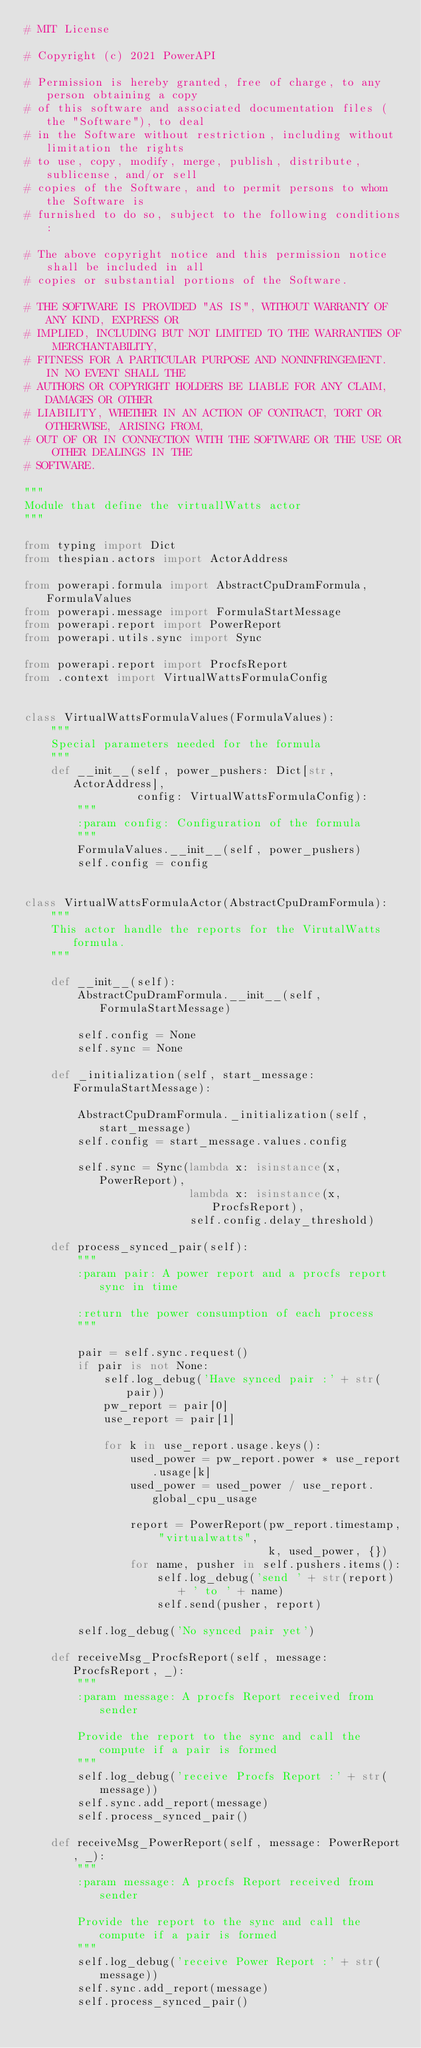<code> <loc_0><loc_0><loc_500><loc_500><_Python_># MIT License

# Copyright (c) 2021 PowerAPI

# Permission is hereby granted, free of charge, to any person obtaining a copy
# of this software and associated documentation files (the "Software"), to deal
# in the Software without restriction, including without limitation the rights
# to use, copy, modify, merge, publish, distribute, sublicense, and/or sell
# copies of the Software, and to permit persons to whom the Software is
# furnished to do so, subject to the following conditions:

# The above copyright notice and this permission notice shall be included in all
# copies or substantial portions of the Software.

# THE SOFTWARE IS PROVIDED "AS IS", WITHOUT WARRANTY OF ANY KIND, EXPRESS OR
# IMPLIED, INCLUDING BUT NOT LIMITED TO THE WARRANTIES OF MERCHANTABILITY,
# FITNESS FOR A PARTICULAR PURPOSE AND NONINFRINGEMENT. IN NO EVENT SHALL THE
# AUTHORS OR COPYRIGHT HOLDERS BE LIABLE FOR ANY CLAIM, DAMAGES OR OTHER
# LIABILITY, WHETHER IN AN ACTION OF CONTRACT, TORT OR OTHERWISE, ARISING FROM,
# OUT OF OR IN CONNECTION WITH THE SOFTWARE OR THE USE OR OTHER DEALINGS IN THE
# SOFTWARE.

"""
Module that define the virtuallWatts actor
"""

from typing import Dict
from thespian.actors import ActorAddress

from powerapi.formula import AbstractCpuDramFormula, FormulaValues
from powerapi.message import FormulaStartMessage
from powerapi.report import PowerReport
from powerapi.utils.sync import Sync

from powerapi.report import ProcfsReport
from .context import VirtualWattsFormulaConfig


class VirtualWattsFormulaValues(FormulaValues):
    """
    Special parameters needed for the formula
    """
    def __init__(self, power_pushers: Dict[str, ActorAddress],
                 config: VirtualWattsFormulaConfig):
        """
        :param config: Configuration of the formula
        """
        FormulaValues.__init__(self, power_pushers)
        self.config = config


class VirtualWattsFormulaActor(AbstractCpuDramFormula):
    """
    This actor handle the reports for the VirutalWatts formula.
    """

    def __init__(self):
        AbstractCpuDramFormula.__init__(self, FormulaStartMessage)

        self.config = None
        self.sync = None

    def _initialization(self, start_message: FormulaStartMessage):

        AbstractCpuDramFormula._initialization(self, start_message)
        self.config = start_message.values.config

        self.sync = Sync(lambda x: isinstance(x, PowerReport),
                         lambda x: isinstance(x, ProcfsReport),
                         self.config.delay_threshold)

    def process_synced_pair(self):
        """
        :param pair: A power report and a procfs report sync in time

        :return the power consumption of each process
        """

        pair = self.sync.request()
        if pair is not None:
            self.log_debug('Have synced pair :' + str(pair))
            pw_report = pair[0]
            use_report = pair[1]

            for k in use_report.usage.keys():
                used_power = pw_report.power * use_report.usage[k]
                used_power = used_power / use_report.global_cpu_usage

                report = PowerReport(pw_report.timestamp, "virtualwatts",
                                     k, used_power, {})
                for name, pusher in self.pushers.items():
                    self.log_debug('send ' + str(report) + ' to ' + name)
                    self.send(pusher, report)

        self.log_debug('No synced pair yet')

    def receiveMsg_ProcfsReport(self, message: ProcfsReport, _):
        """
        :param message: A procfs Report received from sender

        Provide the report to the sync and call the compute if a pair is formed
        """
        self.log_debug('receive Procfs Report :' + str(message))
        self.sync.add_report(message)
        self.process_synced_pair()

    def receiveMsg_PowerReport(self, message: PowerReport, _):
        """
        :param message: A procfs Report received from sender

        Provide the report to the sync and call the compute if a pair is formed
        """
        self.log_debug('receive Power Report :' + str(message))
        self.sync.add_report(message)
        self.process_synced_pair()
</code> 